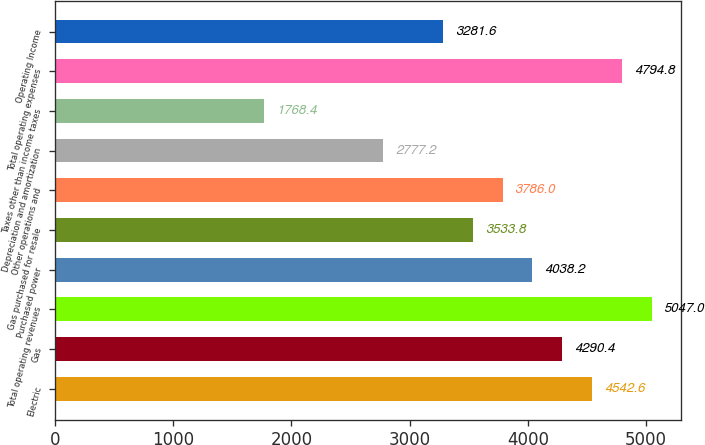Convert chart. <chart><loc_0><loc_0><loc_500><loc_500><bar_chart><fcel>Electric<fcel>Gas<fcel>Total operating revenues<fcel>Purchased power<fcel>Gas purchased for resale<fcel>Other operations and<fcel>Depreciation and amortization<fcel>Taxes other than income taxes<fcel>Total operating expenses<fcel>Operating Income<nl><fcel>4542.6<fcel>4290.4<fcel>5047<fcel>4038.2<fcel>3533.8<fcel>3786<fcel>2777.2<fcel>1768.4<fcel>4794.8<fcel>3281.6<nl></chart> 